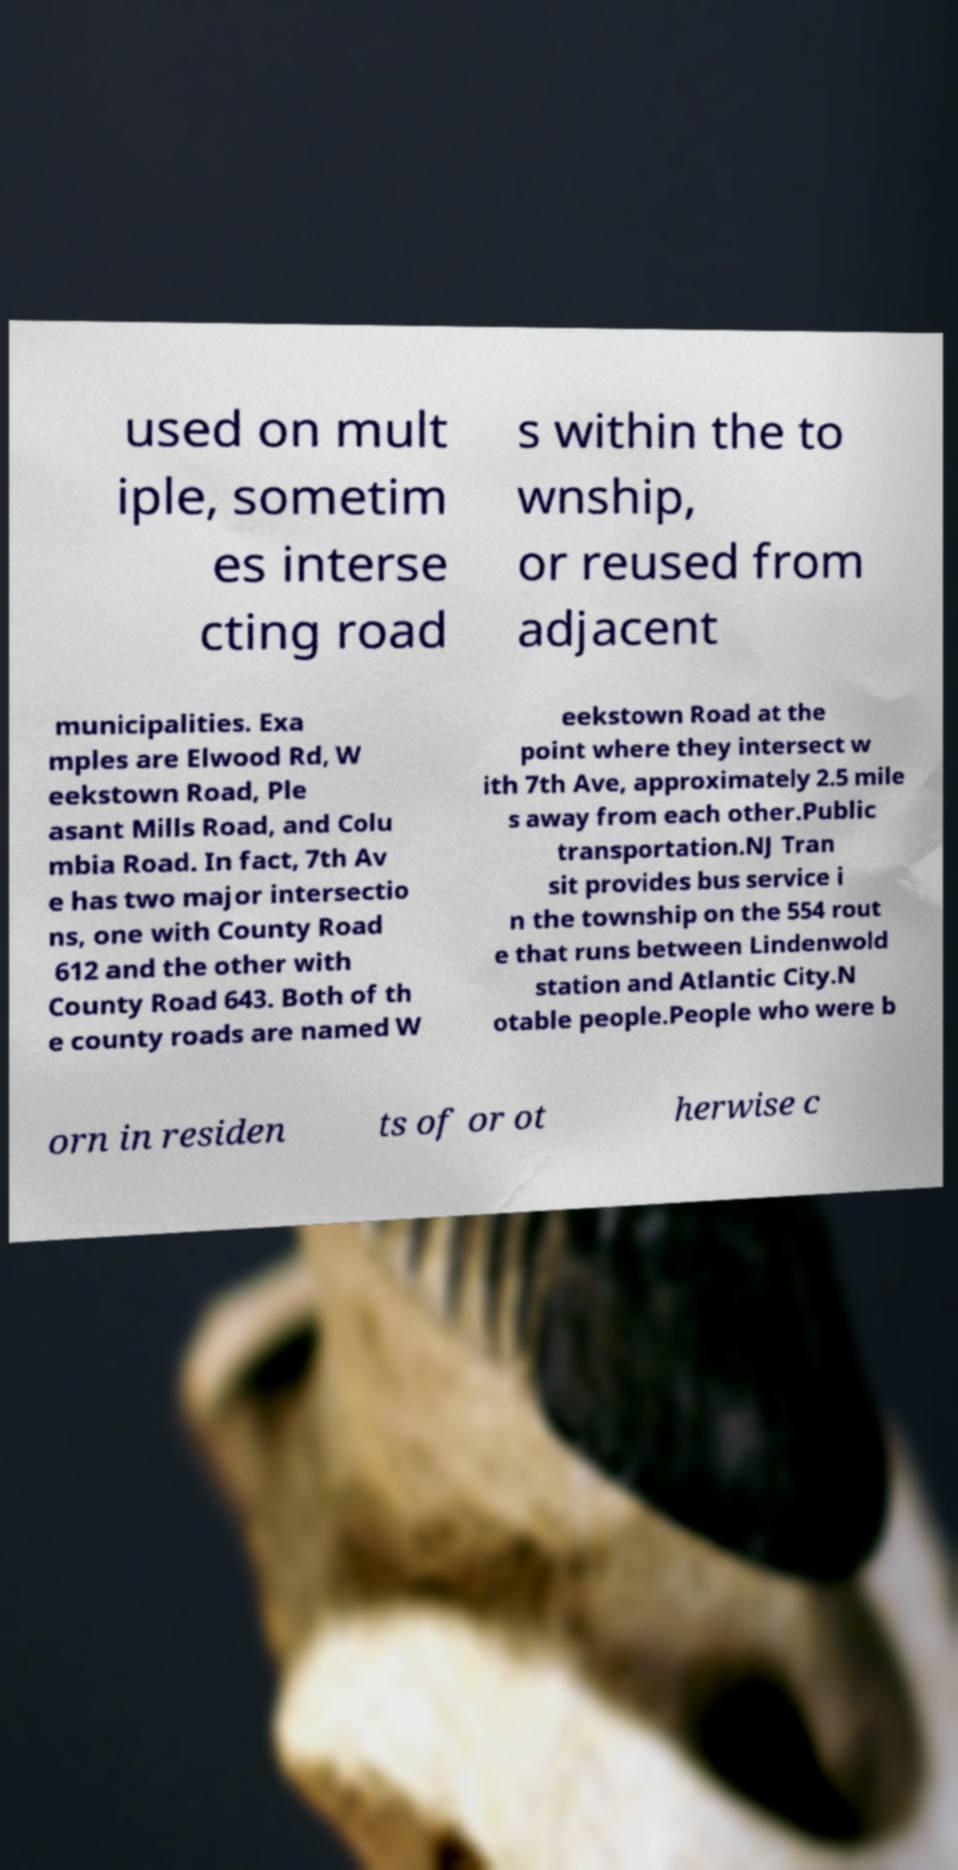Please identify and transcribe the text found in this image. used on mult iple, sometim es interse cting road s within the to wnship, or reused from adjacent municipalities. Exa mples are Elwood Rd, W eekstown Road, Ple asant Mills Road, and Colu mbia Road. In fact, 7th Av e has two major intersectio ns, one with County Road 612 and the other with County Road 643. Both of th e county roads are named W eekstown Road at the point where they intersect w ith 7th Ave, approximately 2.5 mile s away from each other.Public transportation.NJ Tran sit provides bus service i n the township on the 554 rout e that runs between Lindenwold station and Atlantic City.N otable people.People who were b orn in residen ts of or ot herwise c 